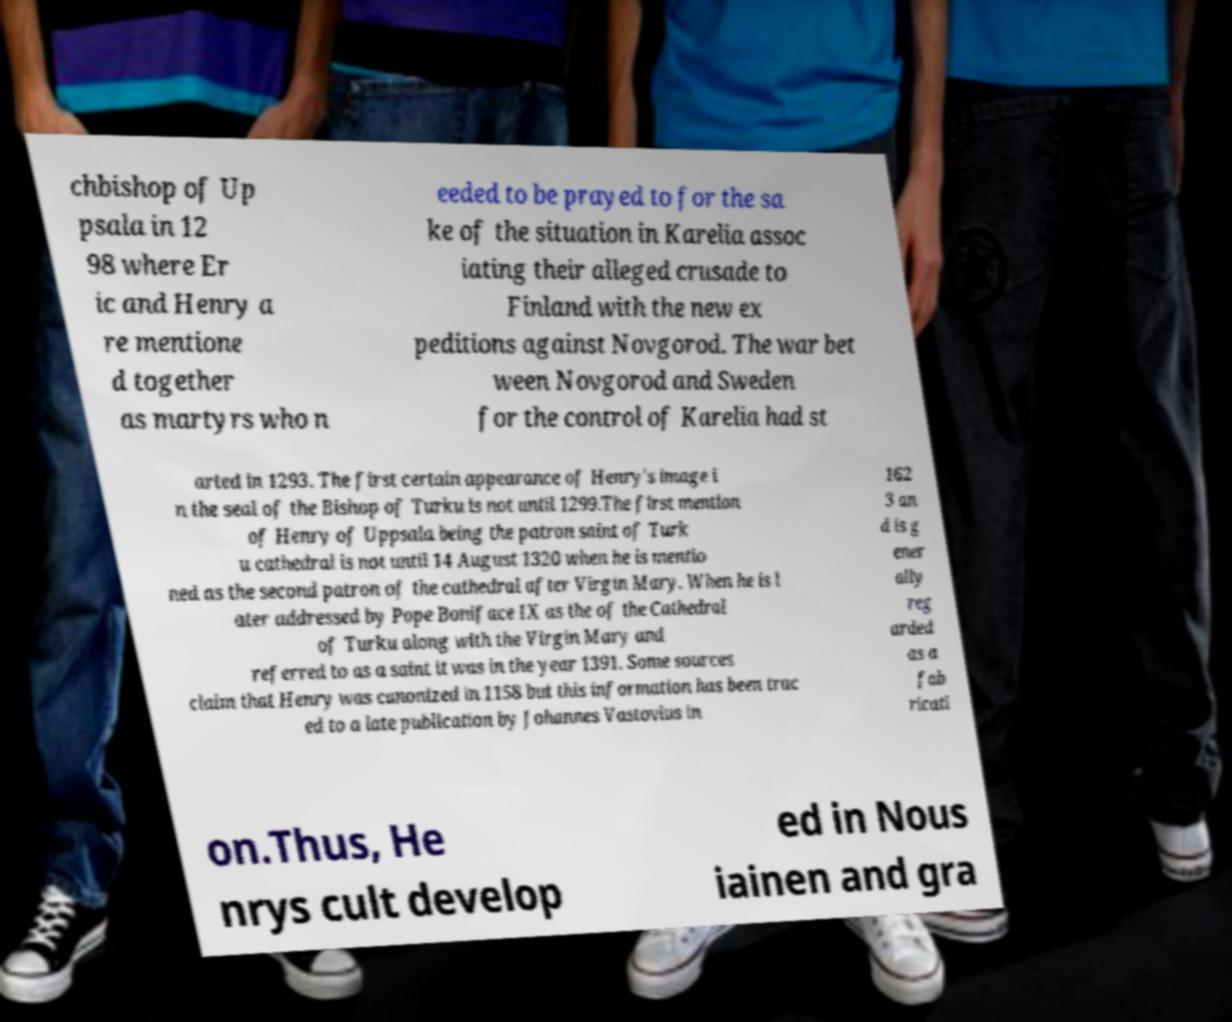Can you read and provide the text displayed in the image?This photo seems to have some interesting text. Can you extract and type it out for me? chbishop of Up psala in 12 98 where Er ic and Henry a re mentione d together as martyrs who n eeded to be prayed to for the sa ke of the situation in Karelia assoc iating their alleged crusade to Finland with the new ex peditions against Novgorod. The war bet ween Novgorod and Sweden for the control of Karelia had st arted in 1293. The first certain appearance of Henry's image i n the seal of the Bishop of Turku is not until 1299.The first mention of Henry of Uppsala being the patron saint of Turk u cathedral is not until 14 August 1320 when he is mentio ned as the second patron of the cathedral after Virgin Mary. When he is l ater addressed by Pope Boniface IX as the of the Cathedral of Turku along with the Virgin Mary and referred to as a saint it was in the year 1391. Some sources claim that Henry was canonized in 1158 but this information has been trac ed to a late publication by Johannes Vastovius in 162 3 an d is g ener ally reg arded as a fab ricati on.Thus, He nrys cult develop ed in Nous iainen and gra 